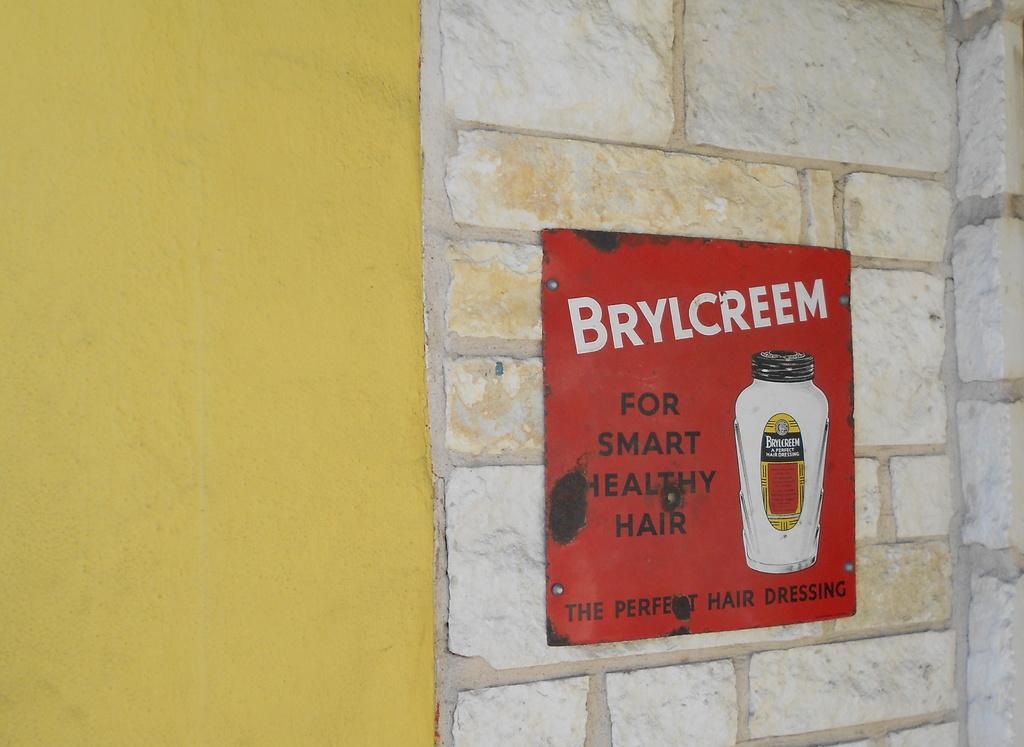What product is for smart, healthy hair?
Your answer should be very brief. Brylcreem. What is the product used for?
Provide a short and direct response. Smart healthy hair. 